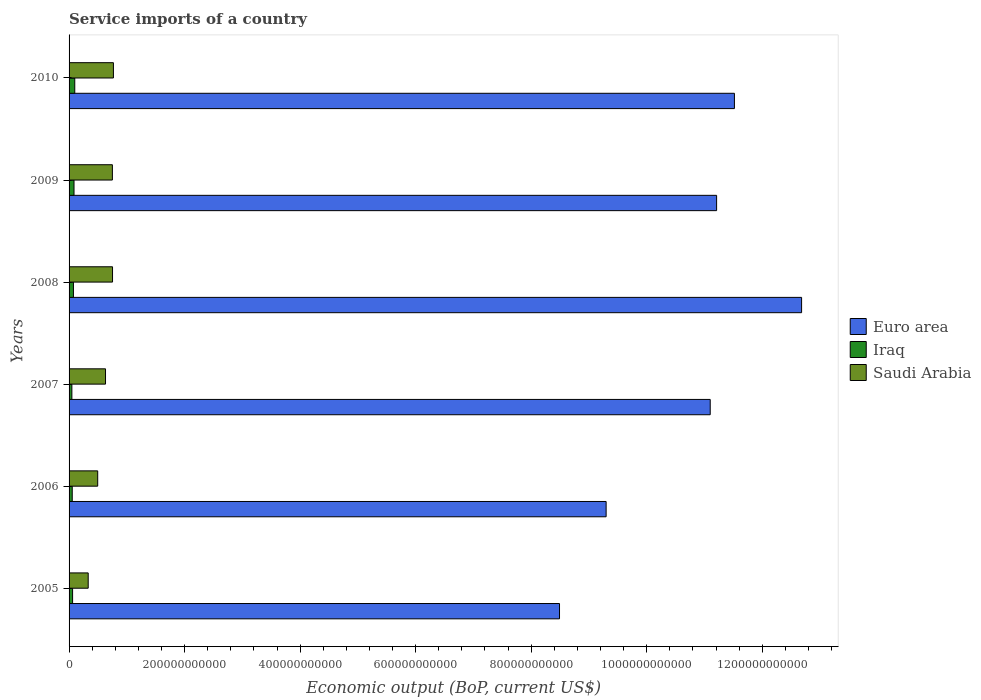How many different coloured bars are there?
Ensure brevity in your answer.  3. Are the number of bars on each tick of the Y-axis equal?
Offer a very short reply. Yes. How many bars are there on the 2nd tick from the top?
Your answer should be very brief. 3. How many bars are there on the 5th tick from the bottom?
Provide a short and direct response. 3. What is the label of the 2nd group of bars from the top?
Give a very brief answer. 2009. In how many cases, is the number of bars for a given year not equal to the number of legend labels?
Ensure brevity in your answer.  0. What is the service imports in Iraq in 2005?
Ensure brevity in your answer.  6.09e+09. Across all years, what is the maximum service imports in Saudi Arabia?
Your response must be concise. 7.68e+1. Across all years, what is the minimum service imports in Iraq?
Your response must be concise. 4.87e+09. In which year was the service imports in Iraq maximum?
Keep it short and to the point. 2010. What is the total service imports in Saudi Arabia in the graph?
Offer a terse response. 3.73e+11. What is the difference between the service imports in Iraq in 2005 and that in 2008?
Offer a terse response. -1.48e+09. What is the difference between the service imports in Euro area in 2010 and the service imports in Saudi Arabia in 2008?
Your response must be concise. 1.08e+12. What is the average service imports in Euro area per year?
Provide a short and direct response. 1.07e+12. In the year 2009, what is the difference between the service imports in Iraq and service imports in Euro area?
Your response must be concise. -1.11e+12. In how many years, is the service imports in Euro area greater than 520000000000 US$?
Give a very brief answer. 6. What is the ratio of the service imports in Saudi Arabia in 2005 to that in 2009?
Give a very brief answer. 0.44. What is the difference between the highest and the second highest service imports in Saudi Arabia?
Your response must be concise. 1.54e+09. What is the difference between the highest and the lowest service imports in Euro area?
Your answer should be compact. 4.19e+11. In how many years, is the service imports in Euro area greater than the average service imports in Euro area taken over all years?
Your response must be concise. 4. Is the sum of the service imports in Saudi Arabia in 2007 and 2010 greater than the maximum service imports in Euro area across all years?
Keep it short and to the point. No. What does the 1st bar from the top in 2009 represents?
Keep it short and to the point. Saudi Arabia. What does the 1st bar from the bottom in 2005 represents?
Keep it short and to the point. Euro area. Is it the case that in every year, the sum of the service imports in Saudi Arabia and service imports in Iraq is greater than the service imports in Euro area?
Provide a short and direct response. No. How many years are there in the graph?
Keep it short and to the point. 6. What is the difference between two consecutive major ticks on the X-axis?
Provide a succinct answer. 2.00e+11. How many legend labels are there?
Provide a short and direct response. 3. What is the title of the graph?
Offer a very short reply. Service imports of a country. Does "Cabo Verde" appear as one of the legend labels in the graph?
Your answer should be compact. No. What is the label or title of the X-axis?
Ensure brevity in your answer.  Economic output (BoP, current US$). What is the Economic output (BoP, current US$) in Euro area in 2005?
Keep it short and to the point. 8.49e+11. What is the Economic output (BoP, current US$) of Iraq in 2005?
Your answer should be compact. 6.09e+09. What is the Economic output (BoP, current US$) in Saudi Arabia in 2005?
Offer a terse response. 3.31e+1. What is the Economic output (BoP, current US$) of Euro area in 2006?
Offer a terse response. 9.30e+11. What is the Economic output (BoP, current US$) of Iraq in 2006?
Provide a short and direct response. 5.49e+09. What is the Economic output (BoP, current US$) in Saudi Arabia in 2006?
Make the answer very short. 4.96e+1. What is the Economic output (BoP, current US$) in Euro area in 2007?
Offer a very short reply. 1.11e+12. What is the Economic output (BoP, current US$) of Iraq in 2007?
Provide a short and direct response. 4.87e+09. What is the Economic output (BoP, current US$) in Saudi Arabia in 2007?
Provide a short and direct response. 6.31e+1. What is the Economic output (BoP, current US$) of Euro area in 2008?
Your answer should be very brief. 1.27e+12. What is the Economic output (BoP, current US$) of Iraq in 2008?
Your answer should be very brief. 7.57e+09. What is the Economic output (BoP, current US$) in Saudi Arabia in 2008?
Give a very brief answer. 7.52e+1. What is the Economic output (BoP, current US$) in Euro area in 2009?
Your response must be concise. 1.12e+12. What is the Economic output (BoP, current US$) in Iraq in 2009?
Give a very brief answer. 8.56e+09. What is the Economic output (BoP, current US$) in Saudi Arabia in 2009?
Keep it short and to the point. 7.50e+1. What is the Economic output (BoP, current US$) of Euro area in 2010?
Provide a succinct answer. 1.15e+12. What is the Economic output (BoP, current US$) in Iraq in 2010?
Make the answer very short. 9.86e+09. What is the Economic output (BoP, current US$) of Saudi Arabia in 2010?
Provide a succinct answer. 7.68e+1. Across all years, what is the maximum Economic output (BoP, current US$) in Euro area?
Offer a very short reply. 1.27e+12. Across all years, what is the maximum Economic output (BoP, current US$) of Iraq?
Your response must be concise. 9.86e+09. Across all years, what is the maximum Economic output (BoP, current US$) of Saudi Arabia?
Give a very brief answer. 7.68e+1. Across all years, what is the minimum Economic output (BoP, current US$) in Euro area?
Your answer should be very brief. 8.49e+11. Across all years, what is the minimum Economic output (BoP, current US$) in Iraq?
Your answer should be very brief. 4.87e+09. Across all years, what is the minimum Economic output (BoP, current US$) of Saudi Arabia?
Offer a terse response. 3.31e+1. What is the total Economic output (BoP, current US$) of Euro area in the graph?
Provide a succinct answer. 6.43e+12. What is the total Economic output (BoP, current US$) of Iraq in the graph?
Provide a short and direct response. 4.24e+1. What is the total Economic output (BoP, current US$) in Saudi Arabia in the graph?
Make the answer very short. 3.73e+11. What is the difference between the Economic output (BoP, current US$) of Euro area in 2005 and that in 2006?
Make the answer very short. -8.07e+1. What is the difference between the Economic output (BoP, current US$) in Iraq in 2005 and that in 2006?
Keep it short and to the point. 6.04e+08. What is the difference between the Economic output (BoP, current US$) of Saudi Arabia in 2005 and that in 2006?
Keep it short and to the point. -1.65e+1. What is the difference between the Economic output (BoP, current US$) of Euro area in 2005 and that in 2007?
Offer a terse response. -2.61e+11. What is the difference between the Economic output (BoP, current US$) in Iraq in 2005 and that in 2007?
Make the answer very short. 1.23e+09. What is the difference between the Economic output (BoP, current US$) of Saudi Arabia in 2005 and that in 2007?
Your answer should be compact. -3.00e+1. What is the difference between the Economic output (BoP, current US$) in Euro area in 2005 and that in 2008?
Your answer should be compact. -4.19e+11. What is the difference between the Economic output (BoP, current US$) of Iraq in 2005 and that in 2008?
Provide a short and direct response. -1.48e+09. What is the difference between the Economic output (BoP, current US$) of Saudi Arabia in 2005 and that in 2008?
Keep it short and to the point. -4.21e+1. What is the difference between the Economic output (BoP, current US$) in Euro area in 2005 and that in 2009?
Your answer should be very brief. -2.72e+11. What is the difference between the Economic output (BoP, current US$) of Iraq in 2005 and that in 2009?
Keep it short and to the point. -2.47e+09. What is the difference between the Economic output (BoP, current US$) in Saudi Arabia in 2005 and that in 2009?
Provide a succinct answer. -4.19e+1. What is the difference between the Economic output (BoP, current US$) in Euro area in 2005 and that in 2010?
Provide a succinct answer. -3.03e+11. What is the difference between the Economic output (BoP, current US$) in Iraq in 2005 and that in 2010?
Make the answer very short. -3.77e+09. What is the difference between the Economic output (BoP, current US$) in Saudi Arabia in 2005 and that in 2010?
Your answer should be compact. -4.37e+1. What is the difference between the Economic output (BoP, current US$) in Euro area in 2006 and that in 2007?
Your answer should be compact. -1.80e+11. What is the difference between the Economic output (BoP, current US$) in Iraq in 2006 and that in 2007?
Keep it short and to the point. 6.24e+08. What is the difference between the Economic output (BoP, current US$) of Saudi Arabia in 2006 and that in 2007?
Keep it short and to the point. -1.35e+1. What is the difference between the Economic output (BoP, current US$) in Euro area in 2006 and that in 2008?
Give a very brief answer. -3.38e+11. What is the difference between the Economic output (BoP, current US$) in Iraq in 2006 and that in 2008?
Offer a terse response. -2.08e+09. What is the difference between the Economic output (BoP, current US$) of Saudi Arabia in 2006 and that in 2008?
Provide a short and direct response. -2.57e+1. What is the difference between the Economic output (BoP, current US$) of Euro area in 2006 and that in 2009?
Offer a terse response. -1.91e+11. What is the difference between the Economic output (BoP, current US$) in Iraq in 2006 and that in 2009?
Make the answer very short. -3.07e+09. What is the difference between the Economic output (BoP, current US$) in Saudi Arabia in 2006 and that in 2009?
Your answer should be very brief. -2.54e+1. What is the difference between the Economic output (BoP, current US$) in Euro area in 2006 and that in 2010?
Give a very brief answer. -2.22e+11. What is the difference between the Economic output (BoP, current US$) in Iraq in 2006 and that in 2010?
Provide a short and direct response. -4.37e+09. What is the difference between the Economic output (BoP, current US$) in Saudi Arabia in 2006 and that in 2010?
Ensure brevity in your answer.  -2.72e+1. What is the difference between the Economic output (BoP, current US$) in Euro area in 2007 and that in 2008?
Provide a succinct answer. -1.58e+11. What is the difference between the Economic output (BoP, current US$) of Iraq in 2007 and that in 2008?
Your answer should be very brief. -2.71e+09. What is the difference between the Economic output (BoP, current US$) of Saudi Arabia in 2007 and that in 2008?
Offer a terse response. -1.21e+1. What is the difference between the Economic output (BoP, current US$) in Euro area in 2007 and that in 2009?
Your answer should be compact. -1.10e+1. What is the difference between the Economic output (BoP, current US$) of Iraq in 2007 and that in 2009?
Your answer should be very brief. -3.70e+09. What is the difference between the Economic output (BoP, current US$) in Saudi Arabia in 2007 and that in 2009?
Provide a short and direct response. -1.19e+1. What is the difference between the Economic output (BoP, current US$) in Euro area in 2007 and that in 2010?
Provide a succinct answer. -4.19e+1. What is the difference between the Economic output (BoP, current US$) in Iraq in 2007 and that in 2010?
Offer a terse response. -5.00e+09. What is the difference between the Economic output (BoP, current US$) of Saudi Arabia in 2007 and that in 2010?
Make the answer very short. -1.37e+1. What is the difference between the Economic output (BoP, current US$) of Euro area in 2008 and that in 2009?
Your answer should be very brief. 1.47e+11. What is the difference between the Economic output (BoP, current US$) in Iraq in 2008 and that in 2009?
Give a very brief answer. -9.91e+08. What is the difference between the Economic output (BoP, current US$) of Saudi Arabia in 2008 and that in 2009?
Provide a succinct answer. 2.40e+08. What is the difference between the Economic output (BoP, current US$) in Euro area in 2008 and that in 2010?
Your answer should be very brief. 1.16e+11. What is the difference between the Economic output (BoP, current US$) in Iraq in 2008 and that in 2010?
Your response must be concise. -2.29e+09. What is the difference between the Economic output (BoP, current US$) in Saudi Arabia in 2008 and that in 2010?
Make the answer very short. -1.54e+09. What is the difference between the Economic output (BoP, current US$) of Euro area in 2009 and that in 2010?
Offer a very short reply. -3.08e+1. What is the difference between the Economic output (BoP, current US$) of Iraq in 2009 and that in 2010?
Provide a short and direct response. -1.30e+09. What is the difference between the Economic output (BoP, current US$) of Saudi Arabia in 2009 and that in 2010?
Offer a very short reply. -1.78e+09. What is the difference between the Economic output (BoP, current US$) of Euro area in 2005 and the Economic output (BoP, current US$) of Iraq in 2006?
Your answer should be very brief. 8.44e+11. What is the difference between the Economic output (BoP, current US$) of Euro area in 2005 and the Economic output (BoP, current US$) of Saudi Arabia in 2006?
Make the answer very short. 8.00e+11. What is the difference between the Economic output (BoP, current US$) of Iraq in 2005 and the Economic output (BoP, current US$) of Saudi Arabia in 2006?
Give a very brief answer. -4.35e+1. What is the difference between the Economic output (BoP, current US$) of Euro area in 2005 and the Economic output (BoP, current US$) of Iraq in 2007?
Offer a terse response. 8.44e+11. What is the difference between the Economic output (BoP, current US$) of Euro area in 2005 and the Economic output (BoP, current US$) of Saudi Arabia in 2007?
Offer a very short reply. 7.86e+11. What is the difference between the Economic output (BoP, current US$) in Iraq in 2005 and the Economic output (BoP, current US$) in Saudi Arabia in 2007?
Your answer should be compact. -5.70e+1. What is the difference between the Economic output (BoP, current US$) in Euro area in 2005 and the Economic output (BoP, current US$) in Iraq in 2008?
Offer a terse response. 8.42e+11. What is the difference between the Economic output (BoP, current US$) of Euro area in 2005 and the Economic output (BoP, current US$) of Saudi Arabia in 2008?
Make the answer very short. 7.74e+11. What is the difference between the Economic output (BoP, current US$) of Iraq in 2005 and the Economic output (BoP, current US$) of Saudi Arabia in 2008?
Your answer should be compact. -6.91e+1. What is the difference between the Economic output (BoP, current US$) of Euro area in 2005 and the Economic output (BoP, current US$) of Iraq in 2009?
Your answer should be very brief. 8.41e+11. What is the difference between the Economic output (BoP, current US$) of Euro area in 2005 and the Economic output (BoP, current US$) of Saudi Arabia in 2009?
Offer a very short reply. 7.74e+11. What is the difference between the Economic output (BoP, current US$) in Iraq in 2005 and the Economic output (BoP, current US$) in Saudi Arabia in 2009?
Keep it short and to the point. -6.89e+1. What is the difference between the Economic output (BoP, current US$) of Euro area in 2005 and the Economic output (BoP, current US$) of Iraq in 2010?
Offer a terse response. 8.39e+11. What is the difference between the Economic output (BoP, current US$) in Euro area in 2005 and the Economic output (BoP, current US$) in Saudi Arabia in 2010?
Keep it short and to the point. 7.72e+11. What is the difference between the Economic output (BoP, current US$) in Iraq in 2005 and the Economic output (BoP, current US$) in Saudi Arabia in 2010?
Your answer should be very brief. -7.07e+1. What is the difference between the Economic output (BoP, current US$) in Euro area in 2006 and the Economic output (BoP, current US$) in Iraq in 2007?
Make the answer very short. 9.25e+11. What is the difference between the Economic output (BoP, current US$) in Euro area in 2006 and the Economic output (BoP, current US$) in Saudi Arabia in 2007?
Give a very brief answer. 8.67e+11. What is the difference between the Economic output (BoP, current US$) of Iraq in 2006 and the Economic output (BoP, current US$) of Saudi Arabia in 2007?
Your answer should be very brief. -5.76e+1. What is the difference between the Economic output (BoP, current US$) in Euro area in 2006 and the Economic output (BoP, current US$) in Iraq in 2008?
Offer a very short reply. 9.22e+11. What is the difference between the Economic output (BoP, current US$) in Euro area in 2006 and the Economic output (BoP, current US$) in Saudi Arabia in 2008?
Make the answer very short. 8.55e+11. What is the difference between the Economic output (BoP, current US$) of Iraq in 2006 and the Economic output (BoP, current US$) of Saudi Arabia in 2008?
Your answer should be compact. -6.97e+1. What is the difference between the Economic output (BoP, current US$) in Euro area in 2006 and the Economic output (BoP, current US$) in Iraq in 2009?
Give a very brief answer. 9.21e+11. What is the difference between the Economic output (BoP, current US$) of Euro area in 2006 and the Economic output (BoP, current US$) of Saudi Arabia in 2009?
Provide a succinct answer. 8.55e+11. What is the difference between the Economic output (BoP, current US$) of Iraq in 2006 and the Economic output (BoP, current US$) of Saudi Arabia in 2009?
Make the answer very short. -6.95e+1. What is the difference between the Economic output (BoP, current US$) in Euro area in 2006 and the Economic output (BoP, current US$) in Iraq in 2010?
Provide a short and direct response. 9.20e+11. What is the difference between the Economic output (BoP, current US$) of Euro area in 2006 and the Economic output (BoP, current US$) of Saudi Arabia in 2010?
Make the answer very short. 8.53e+11. What is the difference between the Economic output (BoP, current US$) of Iraq in 2006 and the Economic output (BoP, current US$) of Saudi Arabia in 2010?
Your answer should be compact. -7.13e+1. What is the difference between the Economic output (BoP, current US$) in Euro area in 2007 and the Economic output (BoP, current US$) in Iraq in 2008?
Offer a very short reply. 1.10e+12. What is the difference between the Economic output (BoP, current US$) in Euro area in 2007 and the Economic output (BoP, current US$) in Saudi Arabia in 2008?
Offer a very short reply. 1.03e+12. What is the difference between the Economic output (BoP, current US$) in Iraq in 2007 and the Economic output (BoP, current US$) in Saudi Arabia in 2008?
Give a very brief answer. -7.04e+1. What is the difference between the Economic output (BoP, current US$) of Euro area in 2007 and the Economic output (BoP, current US$) of Iraq in 2009?
Keep it short and to the point. 1.10e+12. What is the difference between the Economic output (BoP, current US$) of Euro area in 2007 and the Economic output (BoP, current US$) of Saudi Arabia in 2009?
Offer a very short reply. 1.04e+12. What is the difference between the Economic output (BoP, current US$) in Iraq in 2007 and the Economic output (BoP, current US$) in Saudi Arabia in 2009?
Make the answer very short. -7.01e+1. What is the difference between the Economic output (BoP, current US$) of Euro area in 2007 and the Economic output (BoP, current US$) of Iraq in 2010?
Offer a terse response. 1.10e+12. What is the difference between the Economic output (BoP, current US$) in Euro area in 2007 and the Economic output (BoP, current US$) in Saudi Arabia in 2010?
Your answer should be very brief. 1.03e+12. What is the difference between the Economic output (BoP, current US$) in Iraq in 2007 and the Economic output (BoP, current US$) in Saudi Arabia in 2010?
Provide a short and direct response. -7.19e+1. What is the difference between the Economic output (BoP, current US$) of Euro area in 2008 and the Economic output (BoP, current US$) of Iraq in 2009?
Offer a very short reply. 1.26e+12. What is the difference between the Economic output (BoP, current US$) in Euro area in 2008 and the Economic output (BoP, current US$) in Saudi Arabia in 2009?
Your response must be concise. 1.19e+12. What is the difference between the Economic output (BoP, current US$) in Iraq in 2008 and the Economic output (BoP, current US$) in Saudi Arabia in 2009?
Offer a terse response. -6.74e+1. What is the difference between the Economic output (BoP, current US$) in Euro area in 2008 and the Economic output (BoP, current US$) in Iraq in 2010?
Provide a short and direct response. 1.26e+12. What is the difference between the Economic output (BoP, current US$) in Euro area in 2008 and the Economic output (BoP, current US$) in Saudi Arabia in 2010?
Offer a terse response. 1.19e+12. What is the difference between the Economic output (BoP, current US$) of Iraq in 2008 and the Economic output (BoP, current US$) of Saudi Arabia in 2010?
Your answer should be very brief. -6.92e+1. What is the difference between the Economic output (BoP, current US$) of Euro area in 2009 and the Economic output (BoP, current US$) of Iraq in 2010?
Your answer should be very brief. 1.11e+12. What is the difference between the Economic output (BoP, current US$) of Euro area in 2009 and the Economic output (BoP, current US$) of Saudi Arabia in 2010?
Your answer should be very brief. 1.04e+12. What is the difference between the Economic output (BoP, current US$) in Iraq in 2009 and the Economic output (BoP, current US$) in Saudi Arabia in 2010?
Provide a short and direct response. -6.82e+1. What is the average Economic output (BoP, current US$) in Euro area per year?
Your answer should be very brief. 1.07e+12. What is the average Economic output (BoP, current US$) of Iraq per year?
Provide a succinct answer. 7.07e+09. What is the average Economic output (BoP, current US$) of Saudi Arabia per year?
Provide a short and direct response. 6.21e+1. In the year 2005, what is the difference between the Economic output (BoP, current US$) of Euro area and Economic output (BoP, current US$) of Iraq?
Make the answer very short. 8.43e+11. In the year 2005, what is the difference between the Economic output (BoP, current US$) in Euro area and Economic output (BoP, current US$) in Saudi Arabia?
Your answer should be very brief. 8.16e+11. In the year 2005, what is the difference between the Economic output (BoP, current US$) of Iraq and Economic output (BoP, current US$) of Saudi Arabia?
Keep it short and to the point. -2.70e+1. In the year 2006, what is the difference between the Economic output (BoP, current US$) in Euro area and Economic output (BoP, current US$) in Iraq?
Your answer should be compact. 9.24e+11. In the year 2006, what is the difference between the Economic output (BoP, current US$) in Euro area and Economic output (BoP, current US$) in Saudi Arabia?
Ensure brevity in your answer.  8.80e+11. In the year 2006, what is the difference between the Economic output (BoP, current US$) of Iraq and Economic output (BoP, current US$) of Saudi Arabia?
Ensure brevity in your answer.  -4.41e+1. In the year 2007, what is the difference between the Economic output (BoP, current US$) of Euro area and Economic output (BoP, current US$) of Iraq?
Provide a short and direct response. 1.11e+12. In the year 2007, what is the difference between the Economic output (BoP, current US$) in Euro area and Economic output (BoP, current US$) in Saudi Arabia?
Offer a very short reply. 1.05e+12. In the year 2007, what is the difference between the Economic output (BoP, current US$) of Iraq and Economic output (BoP, current US$) of Saudi Arabia?
Your answer should be compact. -5.82e+1. In the year 2008, what is the difference between the Economic output (BoP, current US$) in Euro area and Economic output (BoP, current US$) in Iraq?
Provide a short and direct response. 1.26e+12. In the year 2008, what is the difference between the Economic output (BoP, current US$) in Euro area and Economic output (BoP, current US$) in Saudi Arabia?
Your answer should be very brief. 1.19e+12. In the year 2008, what is the difference between the Economic output (BoP, current US$) in Iraq and Economic output (BoP, current US$) in Saudi Arabia?
Your response must be concise. -6.77e+1. In the year 2009, what is the difference between the Economic output (BoP, current US$) of Euro area and Economic output (BoP, current US$) of Iraq?
Provide a succinct answer. 1.11e+12. In the year 2009, what is the difference between the Economic output (BoP, current US$) of Euro area and Economic output (BoP, current US$) of Saudi Arabia?
Your answer should be very brief. 1.05e+12. In the year 2009, what is the difference between the Economic output (BoP, current US$) of Iraq and Economic output (BoP, current US$) of Saudi Arabia?
Your answer should be very brief. -6.64e+1. In the year 2010, what is the difference between the Economic output (BoP, current US$) of Euro area and Economic output (BoP, current US$) of Iraq?
Give a very brief answer. 1.14e+12. In the year 2010, what is the difference between the Economic output (BoP, current US$) of Euro area and Economic output (BoP, current US$) of Saudi Arabia?
Your answer should be very brief. 1.08e+12. In the year 2010, what is the difference between the Economic output (BoP, current US$) in Iraq and Economic output (BoP, current US$) in Saudi Arabia?
Provide a succinct answer. -6.69e+1. What is the ratio of the Economic output (BoP, current US$) in Euro area in 2005 to that in 2006?
Your answer should be compact. 0.91. What is the ratio of the Economic output (BoP, current US$) in Iraq in 2005 to that in 2006?
Ensure brevity in your answer.  1.11. What is the ratio of the Economic output (BoP, current US$) of Saudi Arabia in 2005 to that in 2006?
Give a very brief answer. 0.67. What is the ratio of the Economic output (BoP, current US$) in Euro area in 2005 to that in 2007?
Your response must be concise. 0.76. What is the ratio of the Economic output (BoP, current US$) of Iraq in 2005 to that in 2007?
Keep it short and to the point. 1.25. What is the ratio of the Economic output (BoP, current US$) in Saudi Arabia in 2005 to that in 2007?
Give a very brief answer. 0.52. What is the ratio of the Economic output (BoP, current US$) of Euro area in 2005 to that in 2008?
Give a very brief answer. 0.67. What is the ratio of the Economic output (BoP, current US$) of Iraq in 2005 to that in 2008?
Your answer should be very brief. 0.8. What is the ratio of the Economic output (BoP, current US$) of Saudi Arabia in 2005 to that in 2008?
Keep it short and to the point. 0.44. What is the ratio of the Economic output (BoP, current US$) of Euro area in 2005 to that in 2009?
Ensure brevity in your answer.  0.76. What is the ratio of the Economic output (BoP, current US$) in Iraq in 2005 to that in 2009?
Provide a succinct answer. 0.71. What is the ratio of the Economic output (BoP, current US$) of Saudi Arabia in 2005 to that in 2009?
Keep it short and to the point. 0.44. What is the ratio of the Economic output (BoP, current US$) in Euro area in 2005 to that in 2010?
Your response must be concise. 0.74. What is the ratio of the Economic output (BoP, current US$) of Iraq in 2005 to that in 2010?
Your answer should be compact. 0.62. What is the ratio of the Economic output (BoP, current US$) in Saudi Arabia in 2005 to that in 2010?
Your answer should be very brief. 0.43. What is the ratio of the Economic output (BoP, current US$) of Euro area in 2006 to that in 2007?
Your response must be concise. 0.84. What is the ratio of the Economic output (BoP, current US$) in Iraq in 2006 to that in 2007?
Ensure brevity in your answer.  1.13. What is the ratio of the Economic output (BoP, current US$) in Saudi Arabia in 2006 to that in 2007?
Provide a short and direct response. 0.79. What is the ratio of the Economic output (BoP, current US$) in Euro area in 2006 to that in 2008?
Keep it short and to the point. 0.73. What is the ratio of the Economic output (BoP, current US$) in Iraq in 2006 to that in 2008?
Ensure brevity in your answer.  0.72. What is the ratio of the Economic output (BoP, current US$) in Saudi Arabia in 2006 to that in 2008?
Your answer should be very brief. 0.66. What is the ratio of the Economic output (BoP, current US$) in Euro area in 2006 to that in 2009?
Offer a very short reply. 0.83. What is the ratio of the Economic output (BoP, current US$) of Iraq in 2006 to that in 2009?
Your response must be concise. 0.64. What is the ratio of the Economic output (BoP, current US$) of Saudi Arabia in 2006 to that in 2009?
Your answer should be very brief. 0.66. What is the ratio of the Economic output (BoP, current US$) of Euro area in 2006 to that in 2010?
Ensure brevity in your answer.  0.81. What is the ratio of the Economic output (BoP, current US$) in Iraq in 2006 to that in 2010?
Make the answer very short. 0.56. What is the ratio of the Economic output (BoP, current US$) in Saudi Arabia in 2006 to that in 2010?
Offer a very short reply. 0.65. What is the ratio of the Economic output (BoP, current US$) of Euro area in 2007 to that in 2008?
Offer a terse response. 0.88. What is the ratio of the Economic output (BoP, current US$) of Iraq in 2007 to that in 2008?
Ensure brevity in your answer.  0.64. What is the ratio of the Economic output (BoP, current US$) of Saudi Arabia in 2007 to that in 2008?
Offer a terse response. 0.84. What is the ratio of the Economic output (BoP, current US$) of Iraq in 2007 to that in 2009?
Your answer should be very brief. 0.57. What is the ratio of the Economic output (BoP, current US$) in Saudi Arabia in 2007 to that in 2009?
Your answer should be very brief. 0.84. What is the ratio of the Economic output (BoP, current US$) of Euro area in 2007 to that in 2010?
Make the answer very short. 0.96. What is the ratio of the Economic output (BoP, current US$) of Iraq in 2007 to that in 2010?
Make the answer very short. 0.49. What is the ratio of the Economic output (BoP, current US$) in Saudi Arabia in 2007 to that in 2010?
Your answer should be very brief. 0.82. What is the ratio of the Economic output (BoP, current US$) of Euro area in 2008 to that in 2009?
Make the answer very short. 1.13. What is the ratio of the Economic output (BoP, current US$) of Iraq in 2008 to that in 2009?
Make the answer very short. 0.88. What is the ratio of the Economic output (BoP, current US$) in Saudi Arabia in 2008 to that in 2009?
Make the answer very short. 1. What is the ratio of the Economic output (BoP, current US$) of Euro area in 2008 to that in 2010?
Your answer should be very brief. 1.1. What is the ratio of the Economic output (BoP, current US$) in Iraq in 2008 to that in 2010?
Offer a very short reply. 0.77. What is the ratio of the Economic output (BoP, current US$) of Saudi Arabia in 2008 to that in 2010?
Offer a terse response. 0.98. What is the ratio of the Economic output (BoP, current US$) in Euro area in 2009 to that in 2010?
Offer a terse response. 0.97. What is the ratio of the Economic output (BoP, current US$) of Iraq in 2009 to that in 2010?
Your response must be concise. 0.87. What is the ratio of the Economic output (BoP, current US$) in Saudi Arabia in 2009 to that in 2010?
Provide a short and direct response. 0.98. What is the difference between the highest and the second highest Economic output (BoP, current US$) of Euro area?
Keep it short and to the point. 1.16e+11. What is the difference between the highest and the second highest Economic output (BoP, current US$) of Iraq?
Your answer should be very brief. 1.30e+09. What is the difference between the highest and the second highest Economic output (BoP, current US$) of Saudi Arabia?
Ensure brevity in your answer.  1.54e+09. What is the difference between the highest and the lowest Economic output (BoP, current US$) of Euro area?
Make the answer very short. 4.19e+11. What is the difference between the highest and the lowest Economic output (BoP, current US$) in Iraq?
Provide a succinct answer. 5.00e+09. What is the difference between the highest and the lowest Economic output (BoP, current US$) in Saudi Arabia?
Your answer should be compact. 4.37e+1. 